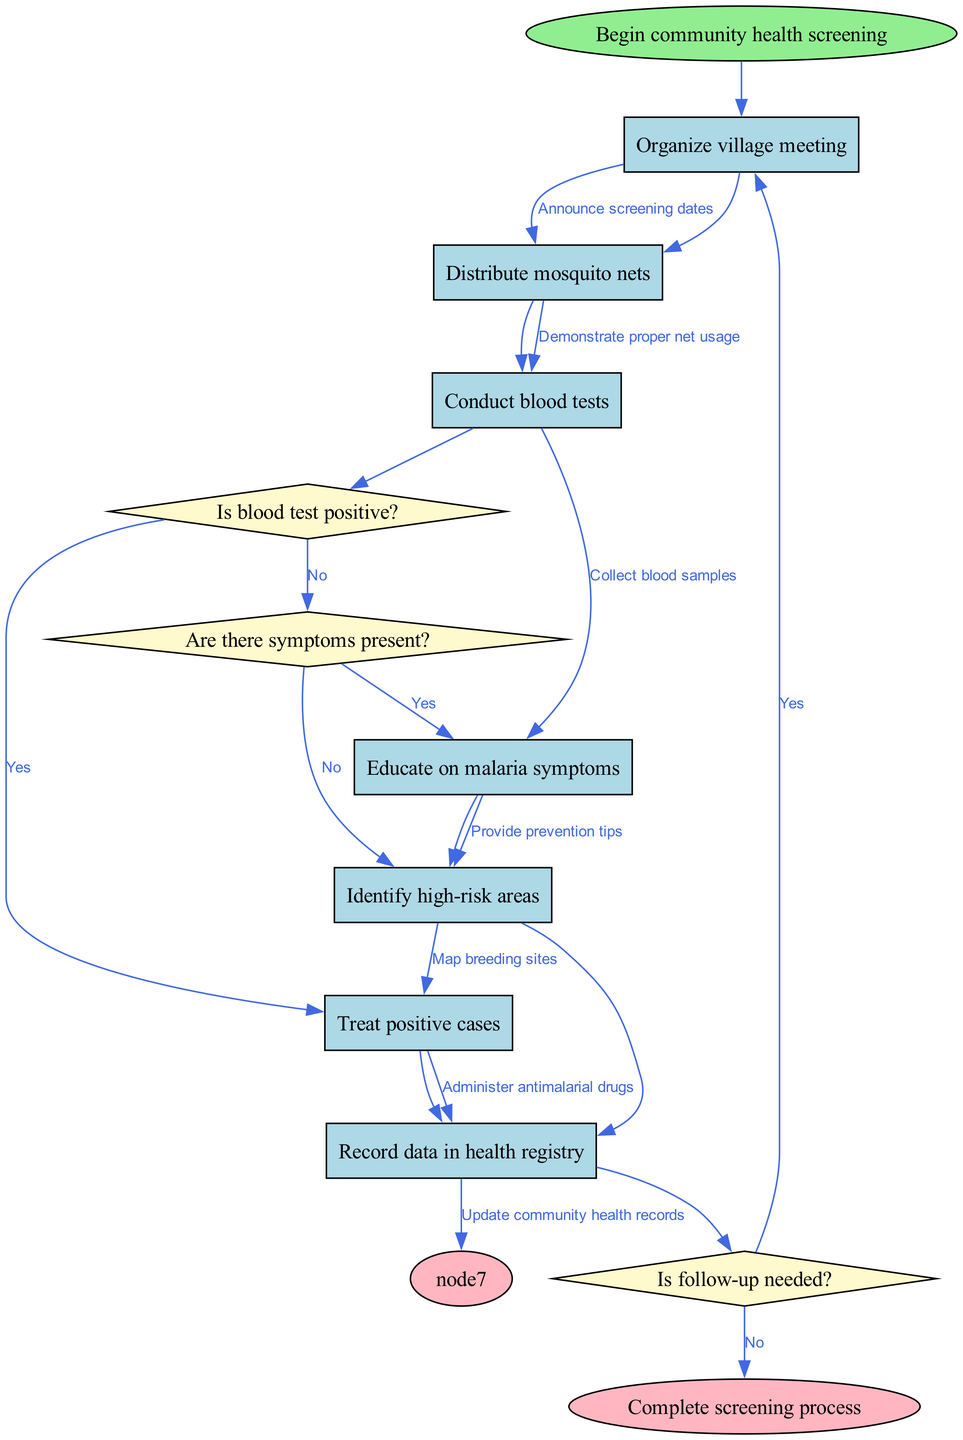What is the first step in the community health screening process? The diagram shows that the first step is labeled as "Begin community health screening," which leads directly to "Organize village meeting."
Answer: Organize village meeting How many decision nodes are present in the diagram? By counting the nodes defined as decisions, the diagram clearly shows there are three: "Is blood test positive?", "Are there symptoms present?", and "Is follow-up needed?"
Answer: 3 What is the action taken if the blood test is positive? The diagram indicates that if the blood test is positive, the flow leads to the node labeled "Treat positive cases," which signifies the action to be taken.
Answer: Treat positive cases What happens if there are no symptoms present? According to the flowchart, if there are no symptoms present, it proceeds to the decision "Is follow-up needed?" which determines further actions.
Answer: Is follow-up needed? Which nodes lead to the end of the screening process? To reach the end, the flow shows that "Update community health records" directly leads to "Complete screening process." Additionally, if the follow-up decision is 'No', it also leads to the end node.
Answer: Update community health records, No If a person is treated, what is the next action? After treating a positive case, the diagram indicates that the next action is to "Record data in health registry," which captures the treatment information for record-keeping.
Answer: Record data in health registry What is the purpose of distributing mosquito nets? The diagram specifies "Distribute mosquito nets" leading to "Demonstrate proper net usage," indicating that the purpose is to educate and promote the usage of these nets for malaria prevention.
Answer: Demonstrate proper net usage What is the last node before completing the screening process? The final action before reaching the end of the process is to "Update community health records," which is the last step that leads to "Complete screening process."
Answer: Update community health records 